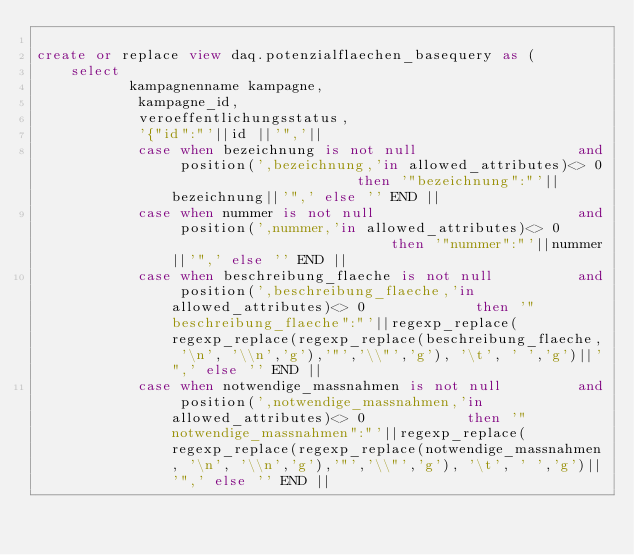<code> <loc_0><loc_0><loc_500><loc_500><_SQL_>
create or replace view daq.potenzialflaechen_basequery as (
    select 
           kampagnenname kampagne,
            kampagne_id,
            veroeffentlichungsstatus,
            '{"id":"'||id ||'",'||
            case when bezeichnung is not null                   and position(',bezeichnung,'in allowed_attributes)<> 0                      then '"bezeichnung":"'||bezeichnung||'",' else '' END ||
            case when nummer is not null                        and position(',nummer,'in allowed_attributes)<> 0                           then '"nummer":"'||nummer||'",' else '' END ||        
            case when beschreibung_flaeche is not null          and position(',beschreibung_flaeche,'in allowed_attributes)<> 0             then '"beschreibung_flaeche":"'||regexp_replace(regexp_replace(regexp_replace(beschreibung_flaeche, '\n', '\\n','g'),'"','\\"','g'), '\t', ' ','g')||'",' else '' END ||        
            case when notwendige_massnahmen is not null         and position(',notwendige_massnahmen,'in allowed_attributes)<> 0            then '"notwendige_massnahmen":"'||regexp_replace(regexp_replace(regexp_replace(notwendige_massnahmen, '\n', '\\n','g'),'"','\\"','g'), '\t', ' ','g')||'",' else '' END ||        </code> 